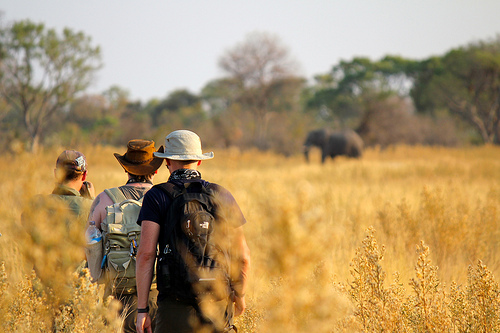Imagine a story where the men in the image have a special mission. What could it be? The men are explorers on a mission to document the migration patterns of elephants in the African savannah. They have traveled for days, navigating through diverse terrains and harsh climates. Carrying necessary equipment in their backpacks, they are now closely observing a herd of elephants from a safe distance to ensure they gather accurate data without disturbing the animals' natural behavior. Their findings will contribute to conservation efforts aiming to protect the elephants from poaching and habitat loss. 